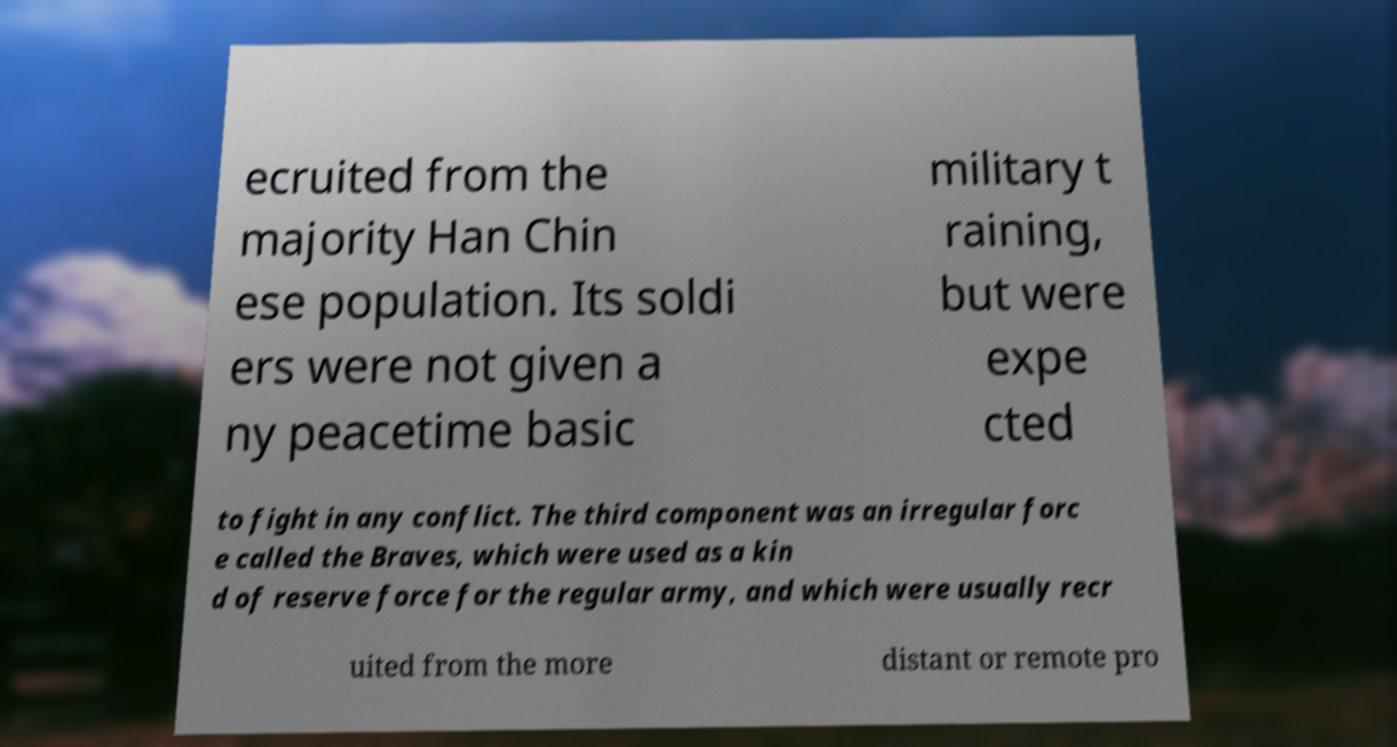Could you extract and type out the text from this image? ecruited from the majority Han Chin ese population. Its soldi ers were not given a ny peacetime basic military t raining, but were expe cted to fight in any conflict. The third component was an irregular forc e called the Braves, which were used as a kin d of reserve force for the regular army, and which were usually recr uited from the more distant or remote pro 